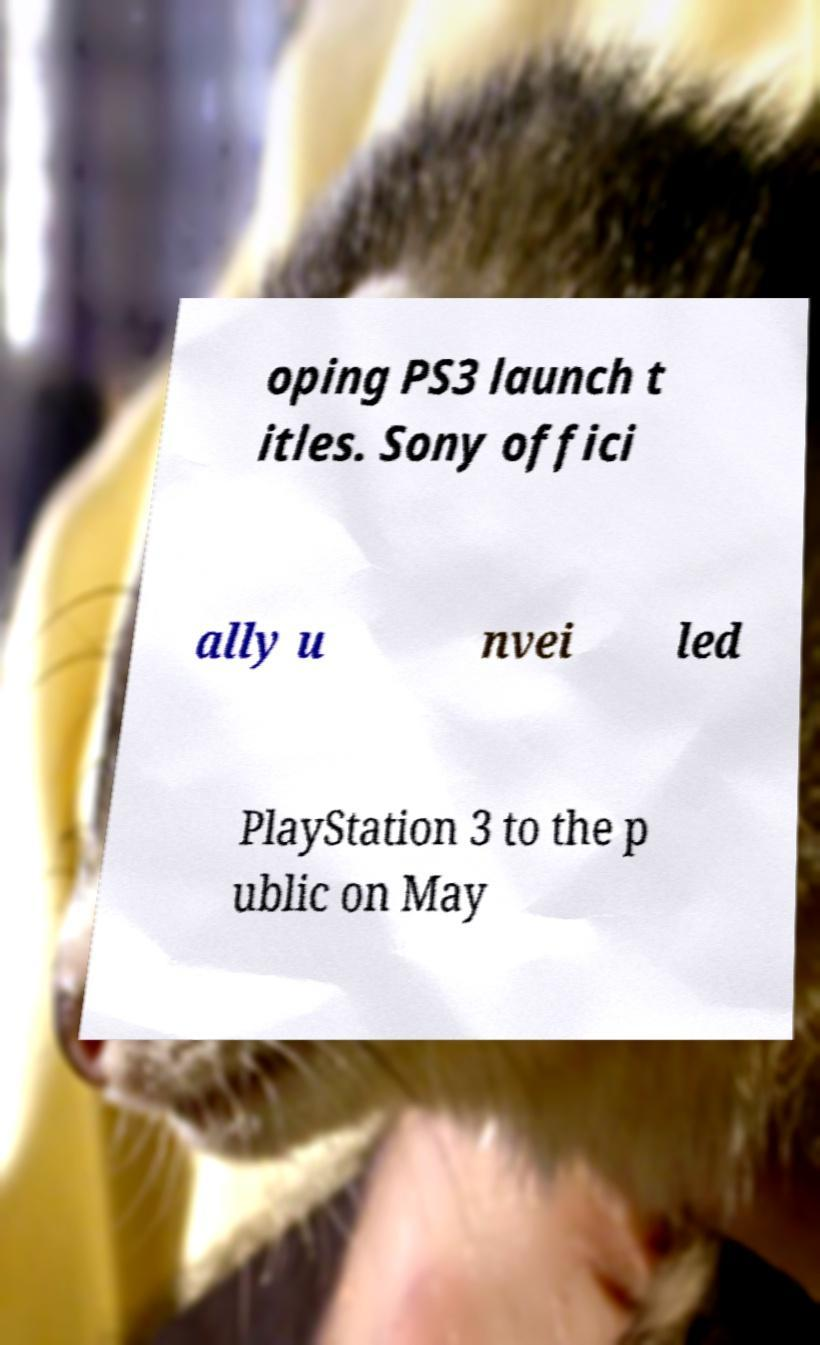Please identify and transcribe the text found in this image. oping PS3 launch t itles. Sony offici ally u nvei led PlayStation 3 to the p ublic on May 